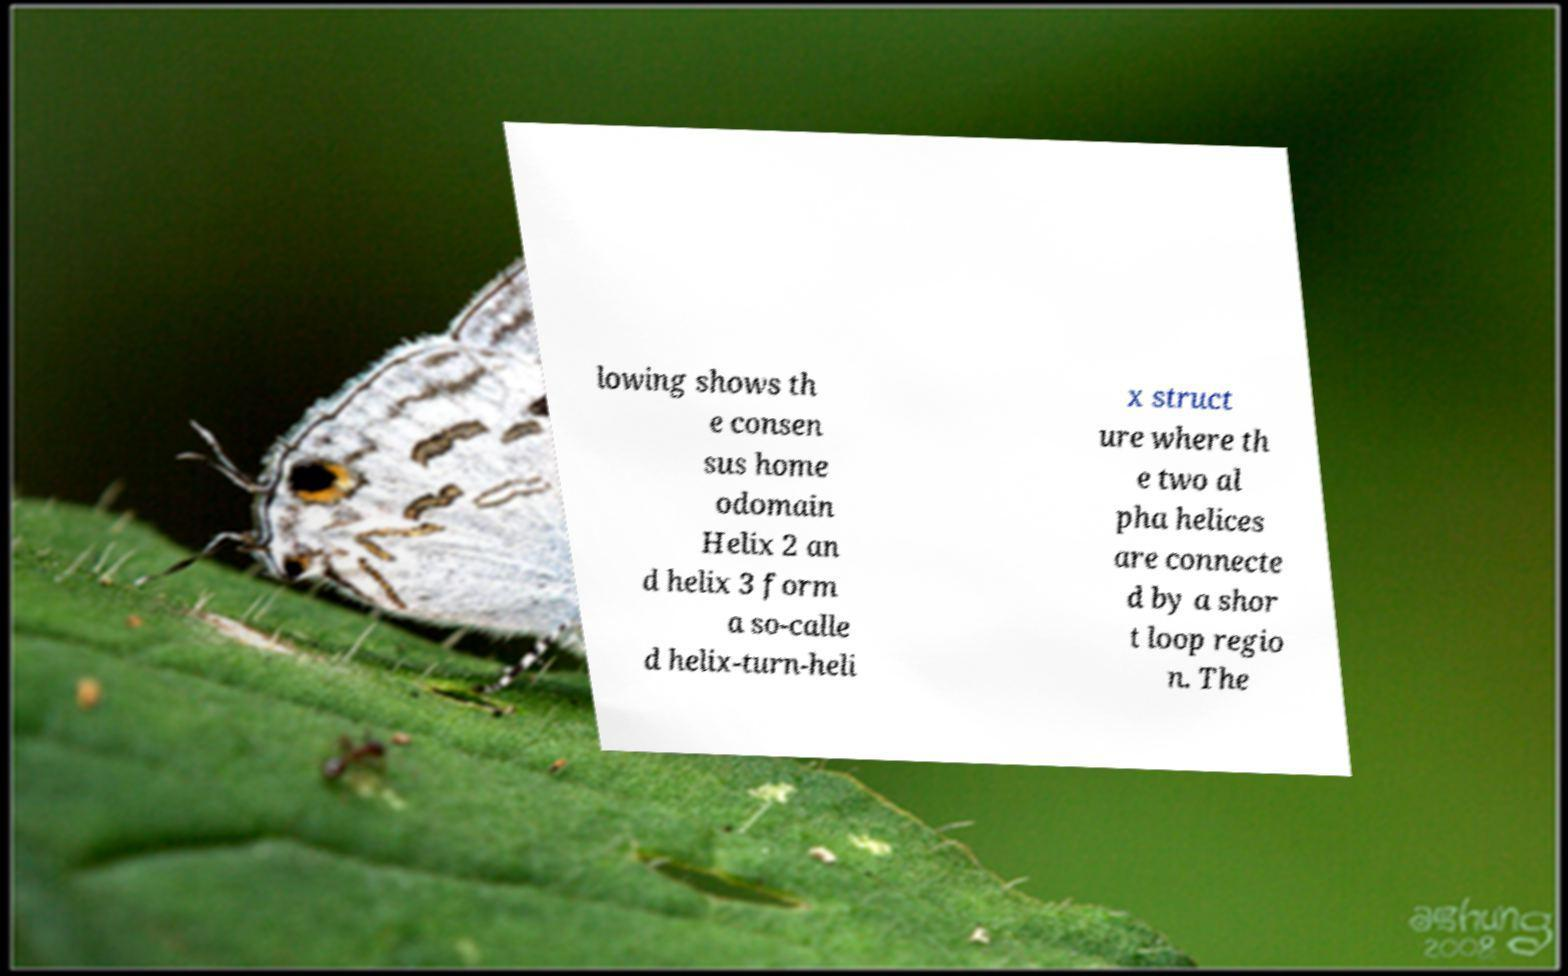Please read and relay the text visible in this image. What does it say? lowing shows th e consen sus home odomain Helix 2 an d helix 3 form a so-calle d helix-turn-heli x struct ure where th e two al pha helices are connecte d by a shor t loop regio n. The 